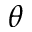<formula> <loc_0><loc_0><loc_500><loc_500>\theta</formula> 